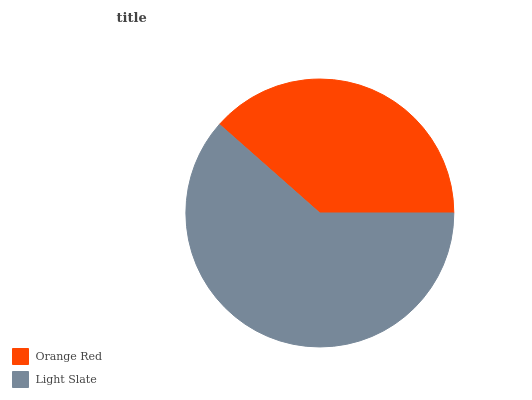Is Orange Red the minimum?
Answer yes or no. Yes. Is Light Slate the maximum?
Answer yes or no. Yes. Is Light Slate the minimum?
Answer yes or no. No. Is Light Slate greater than Orange Red?
Answer yes or no. Yes. Is Orange Red less than Light Slate?
Answer yes or no. Yes. Is Orange Red greater than Light Slate?
Answer yes or no. No. Is Light Slate less than Orange Red?
Answer yes or no. No. Is Light Slate the high median?
Answer yes or no. Yes. Is Orange Red the low median?
Answer yes or no. Yes. Is Orange Red the high median?
Answer yes or no. No. Is Light Slate the low median?
Answer yes or no. No. 